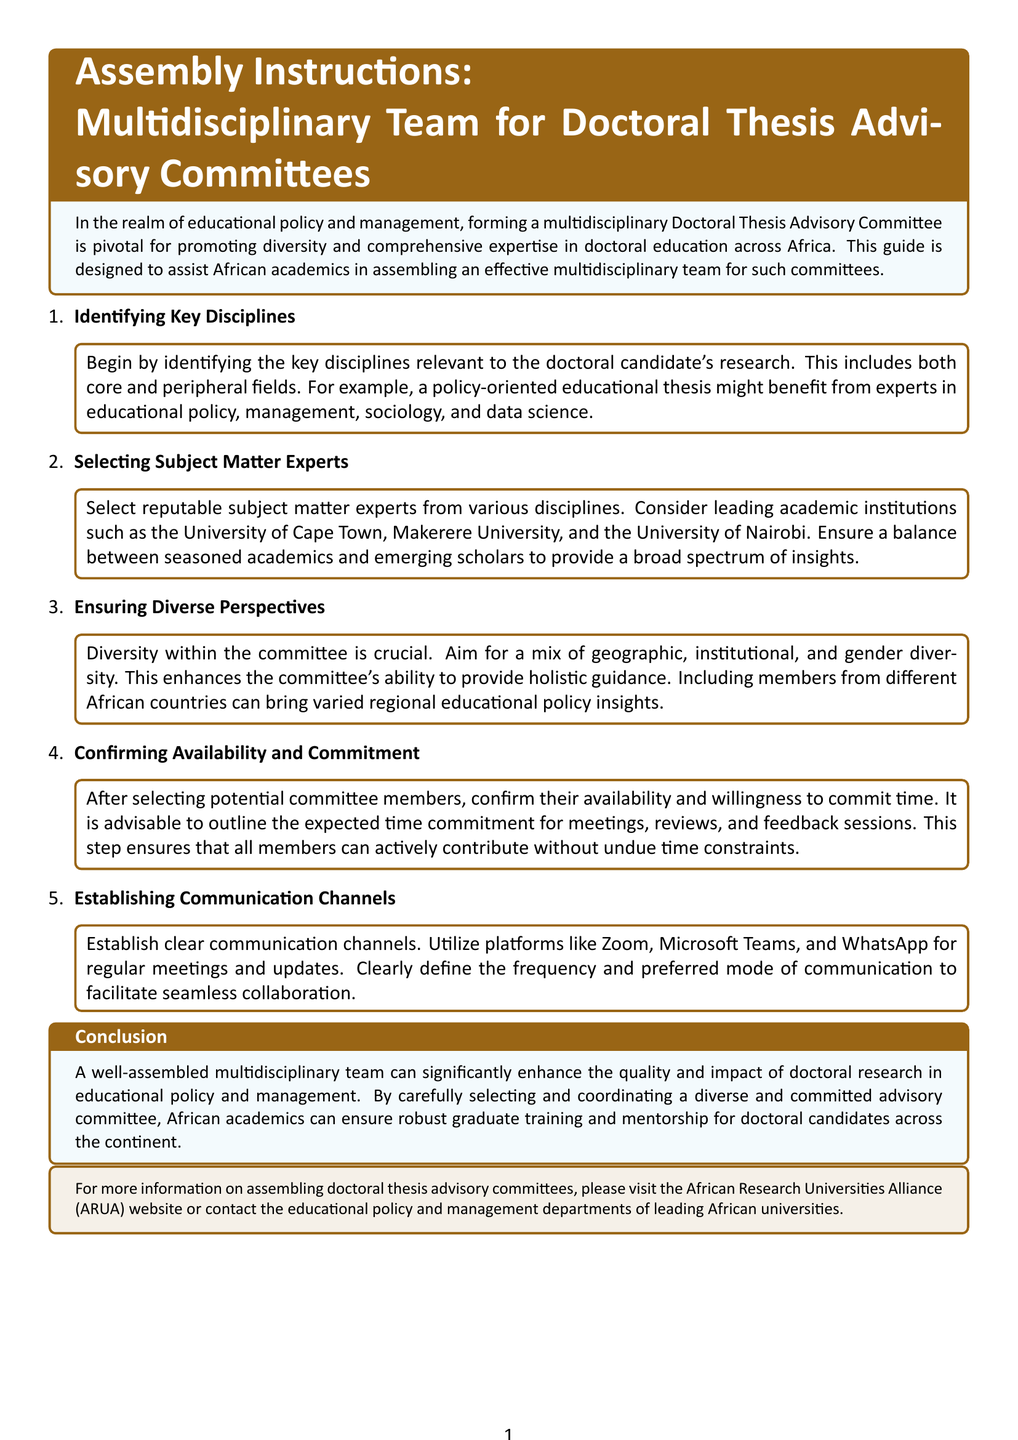What is the title of the document? The title is clearly stated at the top of the document and identifies the main subject it addresses.
Answer: Assembly Instructions: Multidisciplinary Team for Doctoral Thesis Advisory Committees What is the first step in assembling a multidisciplinary team? The first step is to identify the key disciplines relevant to the doctoral candidate's research, as outlined in the document.
Answer: Identifying Key Disciplines Which academic institutions are suggested for selecting experts? The document lists specific institutions known for their academic reputation and influence in Africa.
Answer: University of Cape Town, Makerere University, University of Nairobi What kind of diversity is emphasized for the committee? The document stresses the importance of incorporating a variety of perspectives to enhance guidance offered by the committee.
Answer: Geographic, institutional, and gender diversity What should be confirmed after selecting committee members? The availability and willingness to commit time are significant considerations that need to be verified as per the instructions.
Answer: Availability and Commitment What platforms are recommended for establishing communication? The document mentions specific platforms suitable for regular meetings and updates among committee members.
Answer: Zoom, Microsoft Teams, and WhatsApp What is the aim of assembling a multidisciplinary team? The document explains the overall goal of having a diverse advisory committee in the realm of doctoral education.
Answer: Enhance the quality and impact of doctoral research Which section discusses the conclusion of the assembling process? The conclusion is a distinct part in the document summarizing the benefits of a well-assembled team.
Answer: Conclusion 